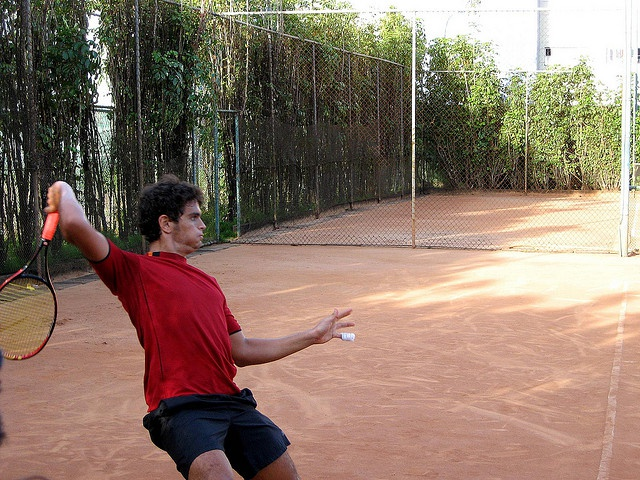Describe the objects in this image and their specific colors. I can see people in black, maroon, brown, and gray tones and tennis racket in black, gray, and tan tones in this image. 